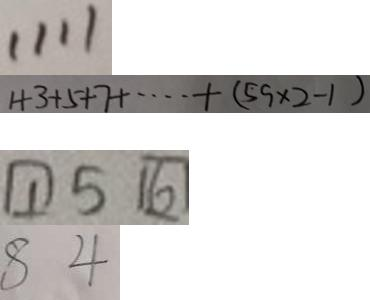Convert formula to latex. <formula><loc_0><loc_0><loc_500><loc_500>1 1 1 1 
 1 + 3 + 5 + 7 + \cdots + ( 5 9 \times 2 - 1 ) 
 \boxed { 1 } 5 \boxed { 6 } 
 8 4</formula> 